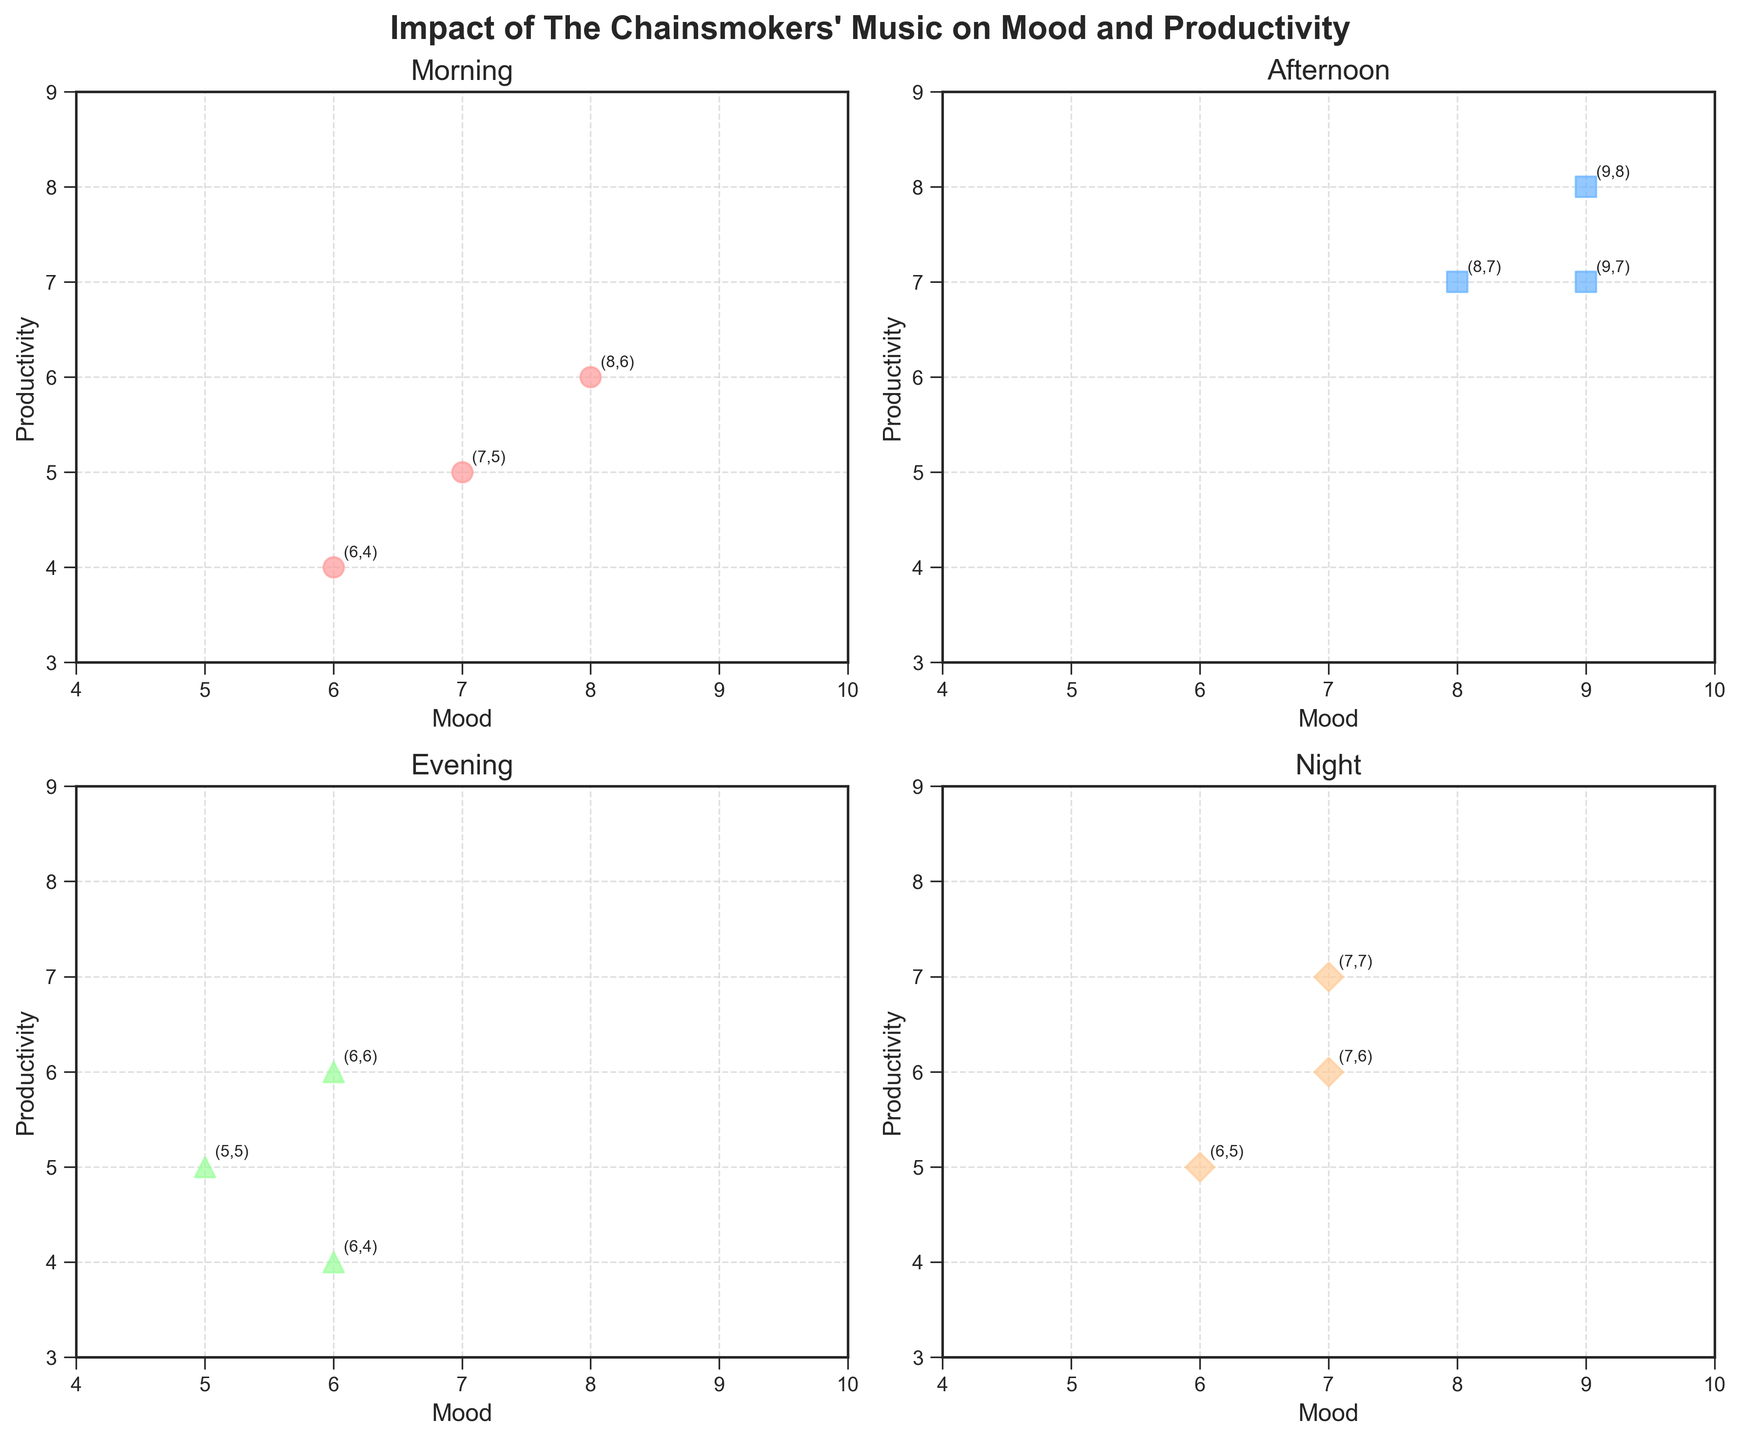What's the title of the figure? The title of the figure is displayed at the top of the subplot. It reads "Impact of The Chainsmokers' Music on Mood and Productivity".
Answer: Impact of The Chainsmokers' Music on Mood and Productivity How many data points are there in the Morning subplot? To find the number of data points, count the instances of the Morning data points in the scatter plot. Each point corresponds to one data entry. There are 3 data points in the Morning subplot.
Answer: 3 What's the highest mood value recorded in the Afternoon? Look at the scatter points in the Afternoon subplot and identify the one with the maximum value on the Mood axis. The highest Mood value recorded in the Afternoon subplot is 9.
Answer: 9 What's the average Productivity level for the Evening time? Locate the Productivity values for the Evening subplot. The values are 6, 5, and 4. Sum them up (6 + 5 + 4 = 15) and divide by the count of values (3). The average Productivity level is 15/3 = 5.
Answer: 5 Which time of day has the most balanced relationship between Mood and Productivity values? Examine the scatter plots for all times of day. The subplot with points closest to a diagonal line indicates balanced relationship. The Night subplot seems to show this with most points along or close to a similar Mood and Productivity value.
Answer: Night In Morning time, what are the respective Mood and Productivity values for the point annotated at (8,6)? Observe the annotations on the points in the Morning subplot and find the one at (8,6). The respective values for this point are Mood: 8 and Productivity: 6.
Answer: Mood: 8, Productivity: 6 Compare the highest Productivity recorded in the Morning to that in the Afternoon. Which is greater? Identify the highest Productivity values in both Morning (6) and Afternoon (8) subplots. Compare them to see which is greater. Afternoon's highest Productivity is greater than Morning's.
Answer: Afternoon What is the general trend of Mood and Productivity during the Evening? Look at the scatter plot for Evening. The overall trend shows that with increasing mood, productivity initially stays constant and then slightly decreases. Thus, there is a varying relationship.
Answer: Varying relationship Which time period has the lowest average Mood value? Calculate the average Mood for each subplot. From observations: Morning (7), Afternoon (8.67), Evening (5.67), Night (6.67). Compare them to see which is the lowest. Evening has the lowest average Mood value.
Answer: Evening Is there a time of day where Productivity increases as Mood increases? A positive correlation indicates that Productivity increases as Mood increases. In Afternoon, there is a clear upward trend. Hence, Afternoon shows this behavior.
Answer: Afternoon 